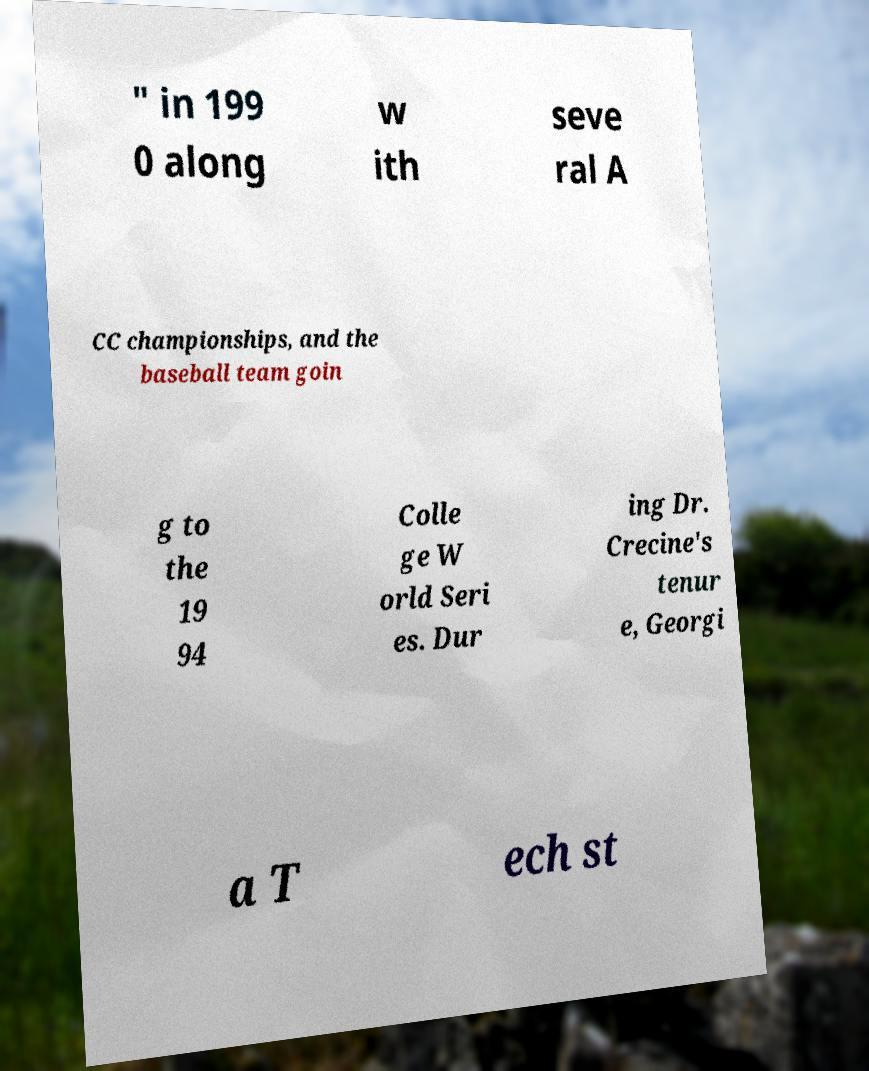Can you accurately transcribe the text from the provided image for me? " in 199 0 along w ith seve ral A CC championships, and the baseball team goin g to the 19 94 Colle ge W orld Seri es. Dur ing Dr. Crecine's tenur e, Georgi a T ech st 